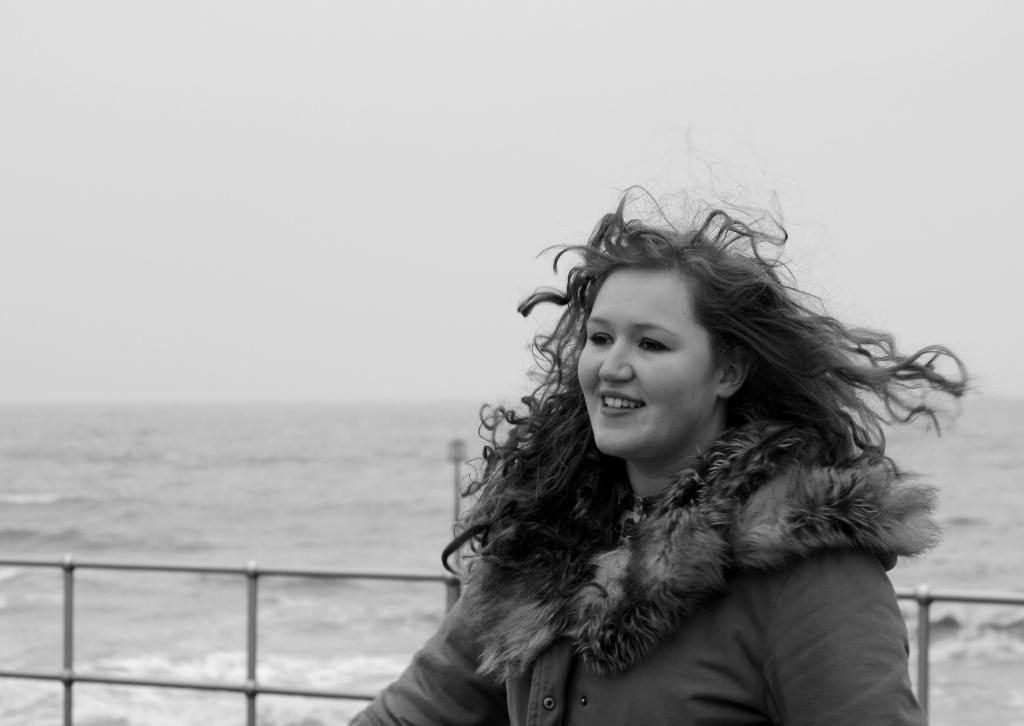Describe this image in one or two sentences. It is a black and white image there is a woman standing in front of a sea and there is a fencing behind the woman,she is wearing a jacket and she is smiling. 